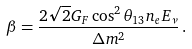Convert formula to latex. <formula><loc_0><loc_0><loc_500><loc_500>\beta = \frac { 2 \sqrt { 2 } G _ { F } \cos ^ { 2 } \theta _ { 1 3 } n _ { e } E _ { \nu } } { \Delta m ^ { 2 } } \, .</formula> 